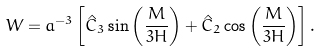<formula> <loc_0><loc_0><loc_500><loc_500>W = a ^ { - 3 } \left [ \hat { C } _ { 3 } \sin \left ( \frac { M } { 3 H } \right ) + \hat { C } _ { 2 } \cos \left ( \frac { M } { 3 H } \right ) \right ] .</formula> 